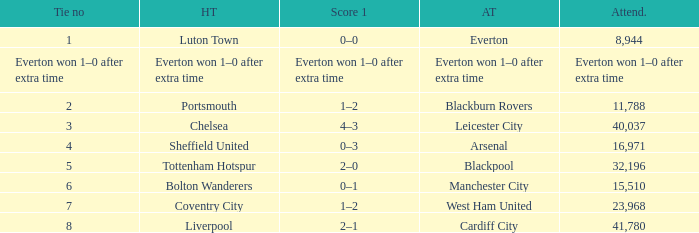What home team had an attendance record of 16,971? Sheffield United. 